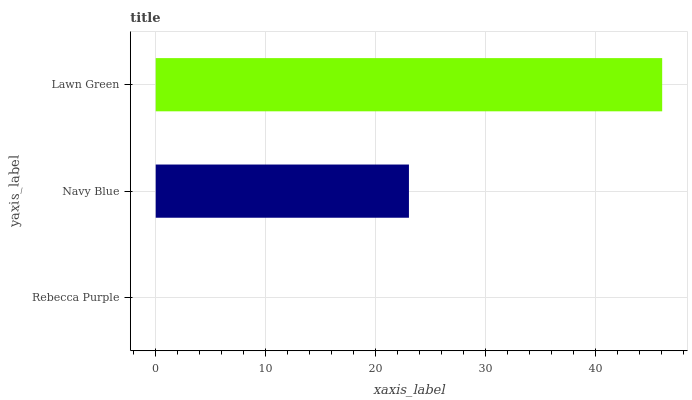Is Rebecca Purple the minimum?
Answer yes or no. Yes. Is Lawn Green the maximum?
Answer yes or no. Yes. Is Navy Blue the minimum?
Answer yes or no. No. Is Navy Blue the maximum?
Answer yes or no. No. Is Navy Blue greater than Rebecca Purple?
Answer yes or no. Yes. Is Rebecca Purple less than Navy Blue?
Answer yes or no. Yes. Is Rebecca Purple greater than Navy Blue?
Answer yes or no. No. Is Navy Blue less than Rebecca Purple?
Answer yes or no. No. Is Navy Blue the high median?
Answer yes or no. Yes. Is Navy Blue the low median?
Answer yes or no. Yes. Is Lawn Green the high median?
Answer yes or no. No. Is Rebecca Purple the low median?
Answer yes or no. No. 